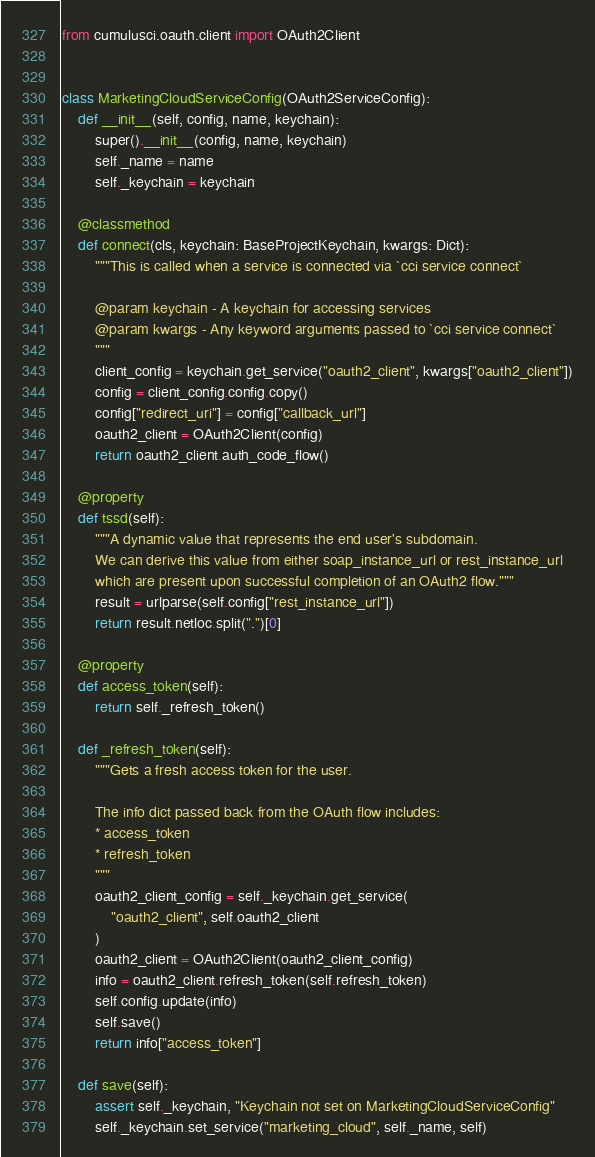Convert code to text. <code><loc_0><loc_0><loc_500><loc_500><_Python_>from cumulusci.oauth.client import OAuth2Client


class MarketingCloudServiceConfig(OAuth2ServiceConfig):
    def __init__(self, config, name, keychain):
        super().__init__(config, name, keychain)
        self._name = name
        self._keychain = keychain

    @classmethod
    def connect(cls, keychain: BaseProjectKeychain, kwargs: Dict):
        """This is called when a service is connected via `cci service connect`

        @param keychain - A keychain for accessing services
        @param kwargs - Any keyword arguments passed to `cci service connect`
        """
        client_config = keychain.get_service("oauth2_client", kwargs["oauth2_client"])
        config = client_config.config.copy()
        config["redirect_uri"] = config["callback_url"]
        oauth2_client = OAuth2Client(config)
        return oauth2_client.auth_code_flow()

    @property
    def tssd(self):
        """A dynamic value that represents the end user's subdomain.
        We can derive this value from either soap_instance_url or rest_instance_url
        which are present upon successful completion of an OAuth2 flow."""
        result = urlparse(self.config["rest_instance_url"])
        return result.netloc.split(".")[0]

    @property
    def access_token(self):
        return self._refresh_token()

    def _refresh_token(self):
        """Gets a fresh access token for the user.

        The info dict passed back from the OAuth flow includes:
        * access_token
        * refresh_token
        """
        oauth2_client_config = self._keychain.get_service(
            "oauth2_client", self.oauth2_client
        )
        oauth2_client = OAuth2Client(oauth2_client_config)
        info = oauth2_client.refresh_token(self.refresh_token)
        self.config.update(info)
        self.save()
        return info["access_token"]

    def save(self):
        assert self._keychain, "Keychain not set on MarketingCloudServiceConfig"
        self._keychain.set_service("marketing_cloud", self._name, self)
</code> 